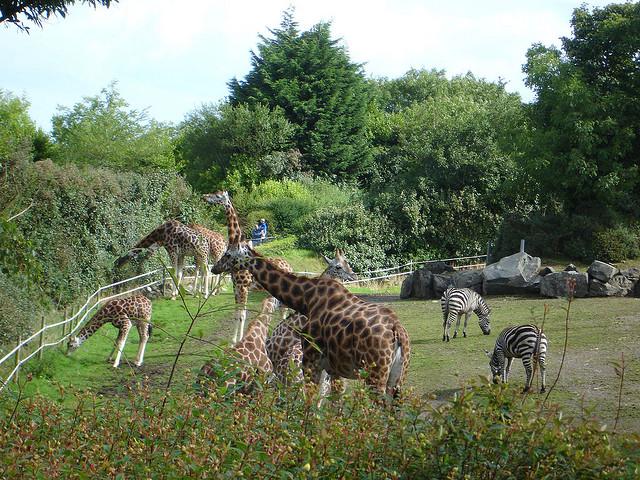How many animals are there?
Quick response, please. 8. Are all of these animals the same species?
Answer briefly. No. Is this picture in the wild?
Write a very short answer. No. How many people are visible?
Answer briefly. 0. 